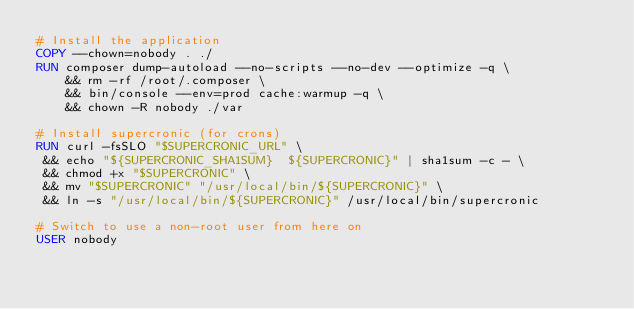Convert code to text. <code><loc_0><loc_0><loc_500><loc_500><_Dockerfile_># Install the application
COPY --chown=nobody . ./
RUN composer dump-autoload --no-scripts --no-dev --optimize -q \
    && rm -rf /root/.composer \
    && bin/console --env=prod cache:warmup -q \
    && chown -R nobody ./var

# Install supercronic (for crons)
RUN curl -fsSLO "$SUPERCRONIC_URL" \
 && echo "${SUPERCRONIC_SHA1SUM}  ${SUPERCRONIC}" | sha1sum -c - \
 && chmod +x "$SUPERCRONIC" \
 && mv "$SUPERCRONIC" "/usr/local/bin/${SUPERCRONIC}" \
 && ln -s "/usr/local/bin/${SUPERCRONIC}" /usr/local/bin/supercronic

# Switch to use a non-root user from here on
USER nobody
</code> 